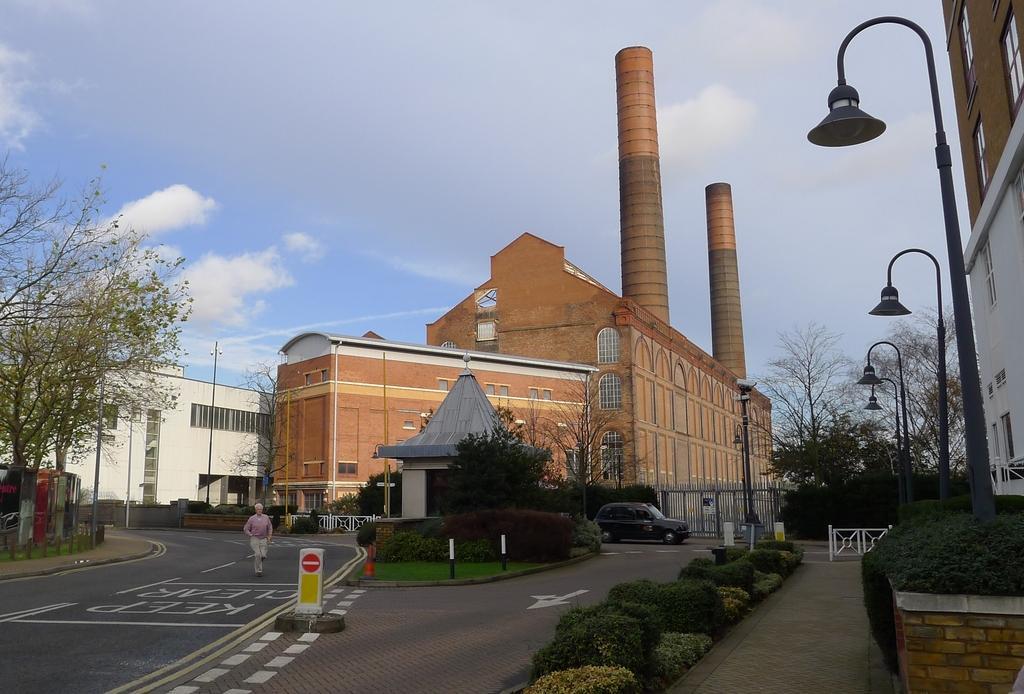Could you give a brief overview of what you see in this image? In this image we can see a person on the road. Image also consists of buildings, smoke towers and also trees and light poles. We can also see shrubs in this image. There is also vehicle passing on the road. At the top there is sky with some clouds. 